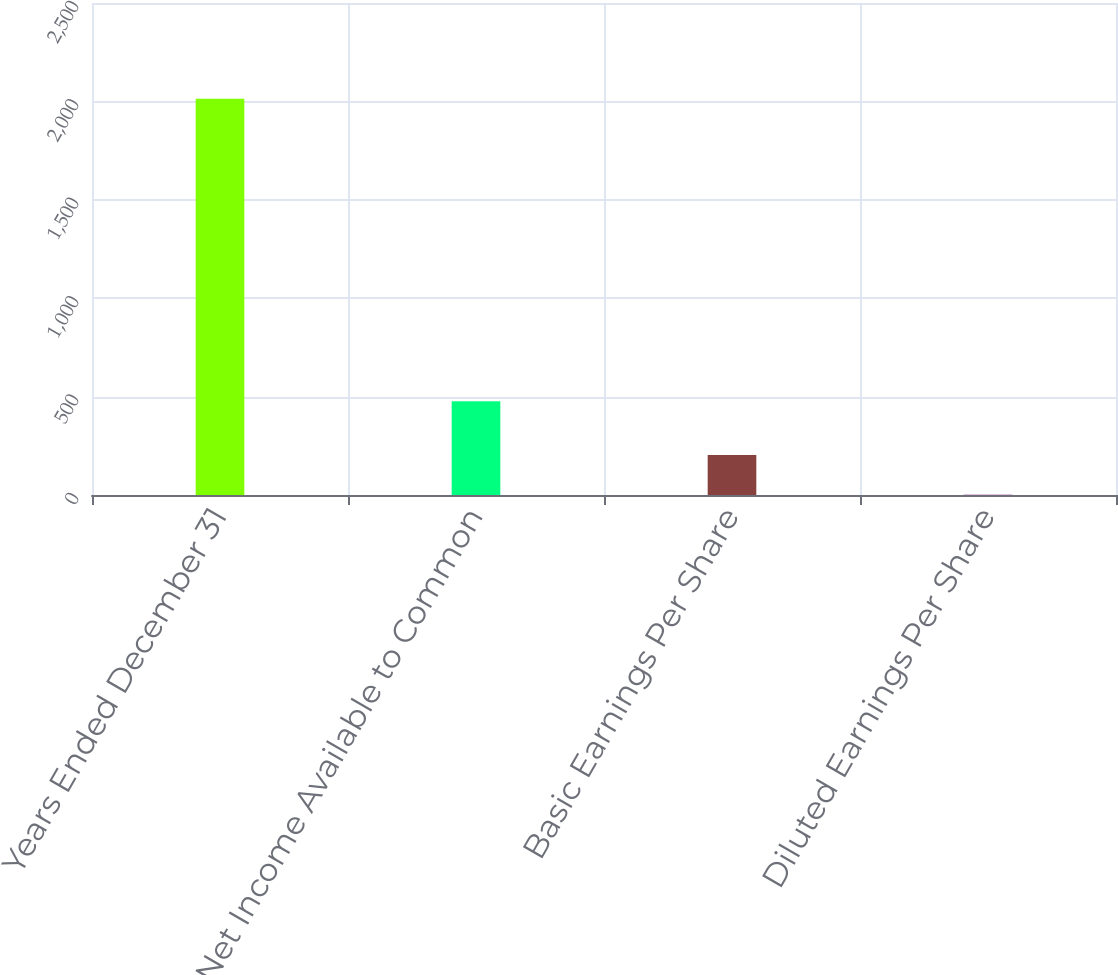Convert chart. <chart><loc_0><loc_0><loc_500><loc_500><bar_chart><fcel>Years Ended December 31<fcel>Net Income Available to Common<fcel>Basic Earnings Per Share<fcel>Diluted Earnings Per Share<nl><fcel>2014<fcel>477<fcel>202.97<fcel>1.74<nl></chart> 